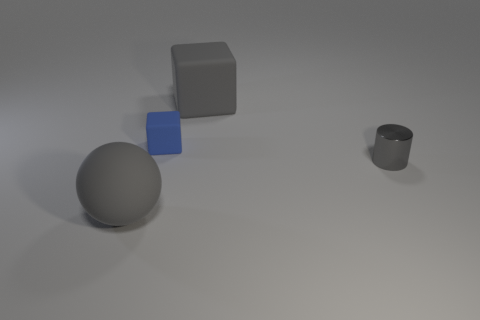Add 1 metal things. How many objects exist? 5 Subtract all cylinders. How many objects are left? 3 Subtract all red matte objects. Subtract all blue blocks. How many objects are left? 3 Add 2 matte blocks. How many matte blocks are left? 4 Add 3 big gray balls. How many big gray balls exist? 4 Subtract 0 purple cylinders. How many objects are left? 4 